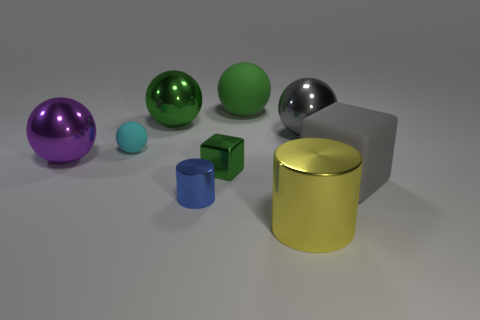Add 1 tiny green things. How many objects exist? 10 Subtract all blocks. How many objects are left? 7 Add 2 small blue shiny objects. How many small blue shiny objects exist? 3 Subtract all green balls. How many balls are left? 3 Subtract all gray metallic balls. How many balls are left? 4 Subtract 0 purple cubes. How many objects are left? 9 Subtract 1 balls. How many balls are left? 4 Subtract all blue cylinders. Subtract all purple blocks. How many cylinders are left? 1 Subtract all gray cylinders. How many red spheres are left? 0 Subtract all cyan matte things. Subtract all big objects. How many objects are left? 2 